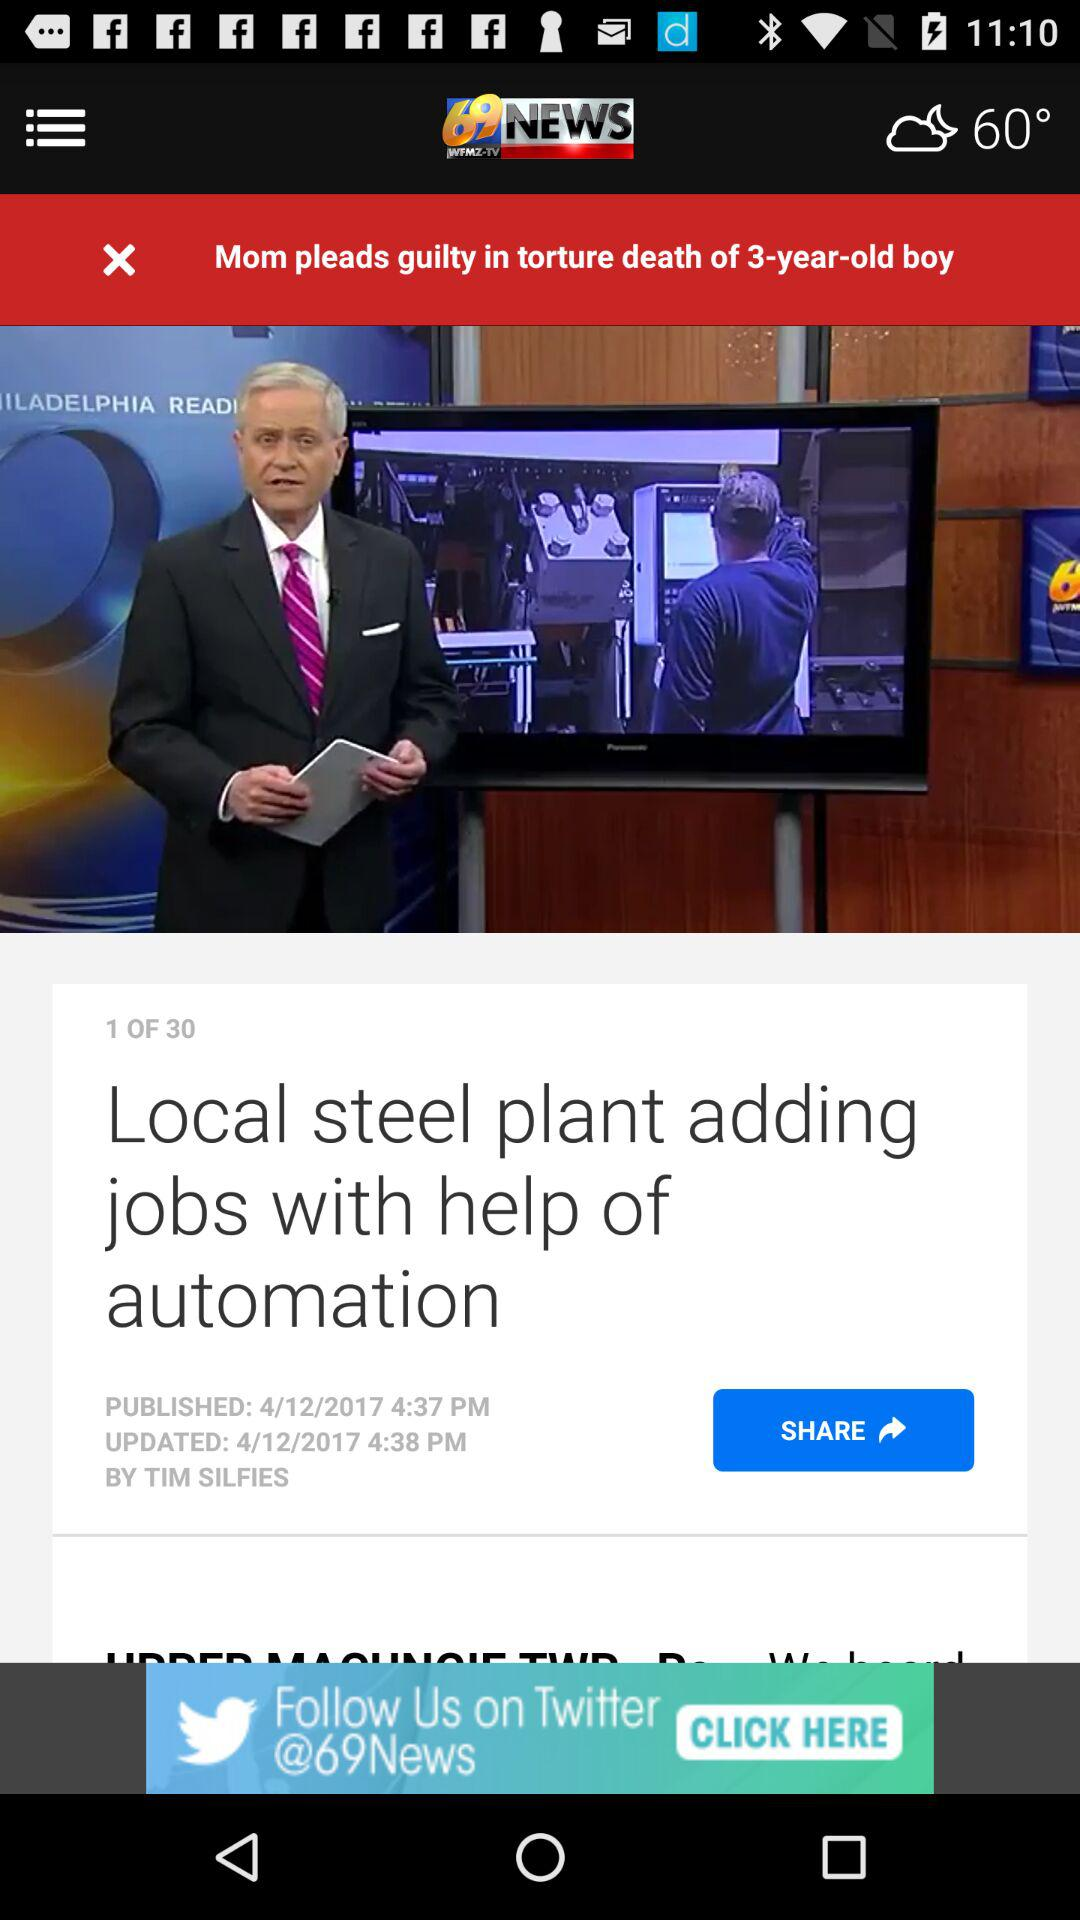What was the age of the boy who died? The boy was 3 years old. 